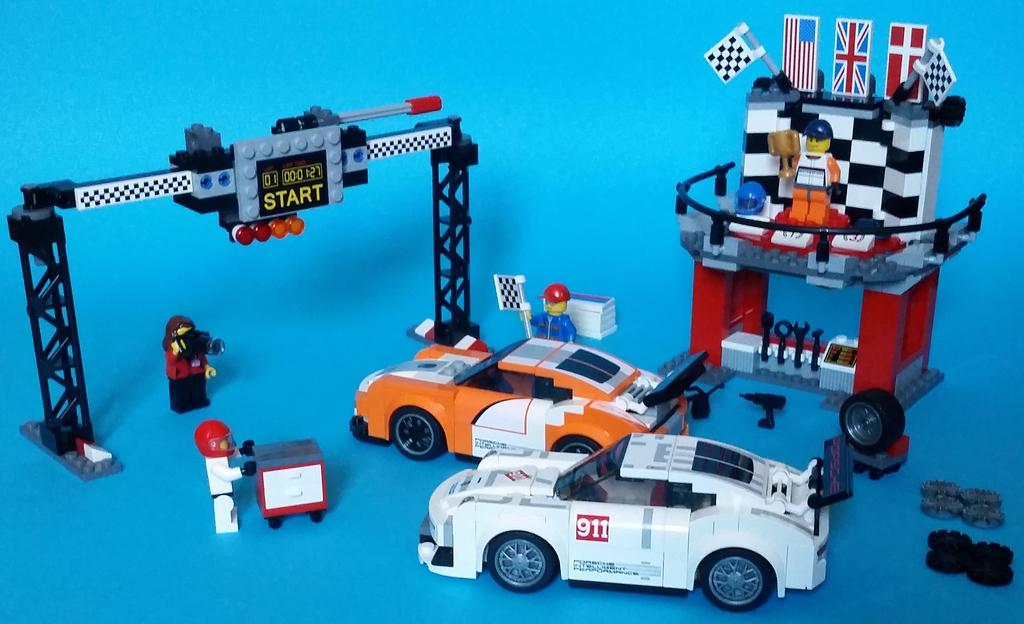What type of toy is present in the image? There are lego cars in the image. Can you identify any people in the image? Yes, there are people in the image. What structural elements can be seen in the image? There are trusses in the image. What type of illumination is present in the image? There are lights in the image. What decorative elements are present in the image? There are flags in the image. What type of protective gear is present in the image? There is a helmet in the image. What objects are placed on the surface in the image? There are objects on the surface in the image. What color is the chalk used to draw on the surface in the image? There is no chalk present in the image, so we cannot determine its color. 